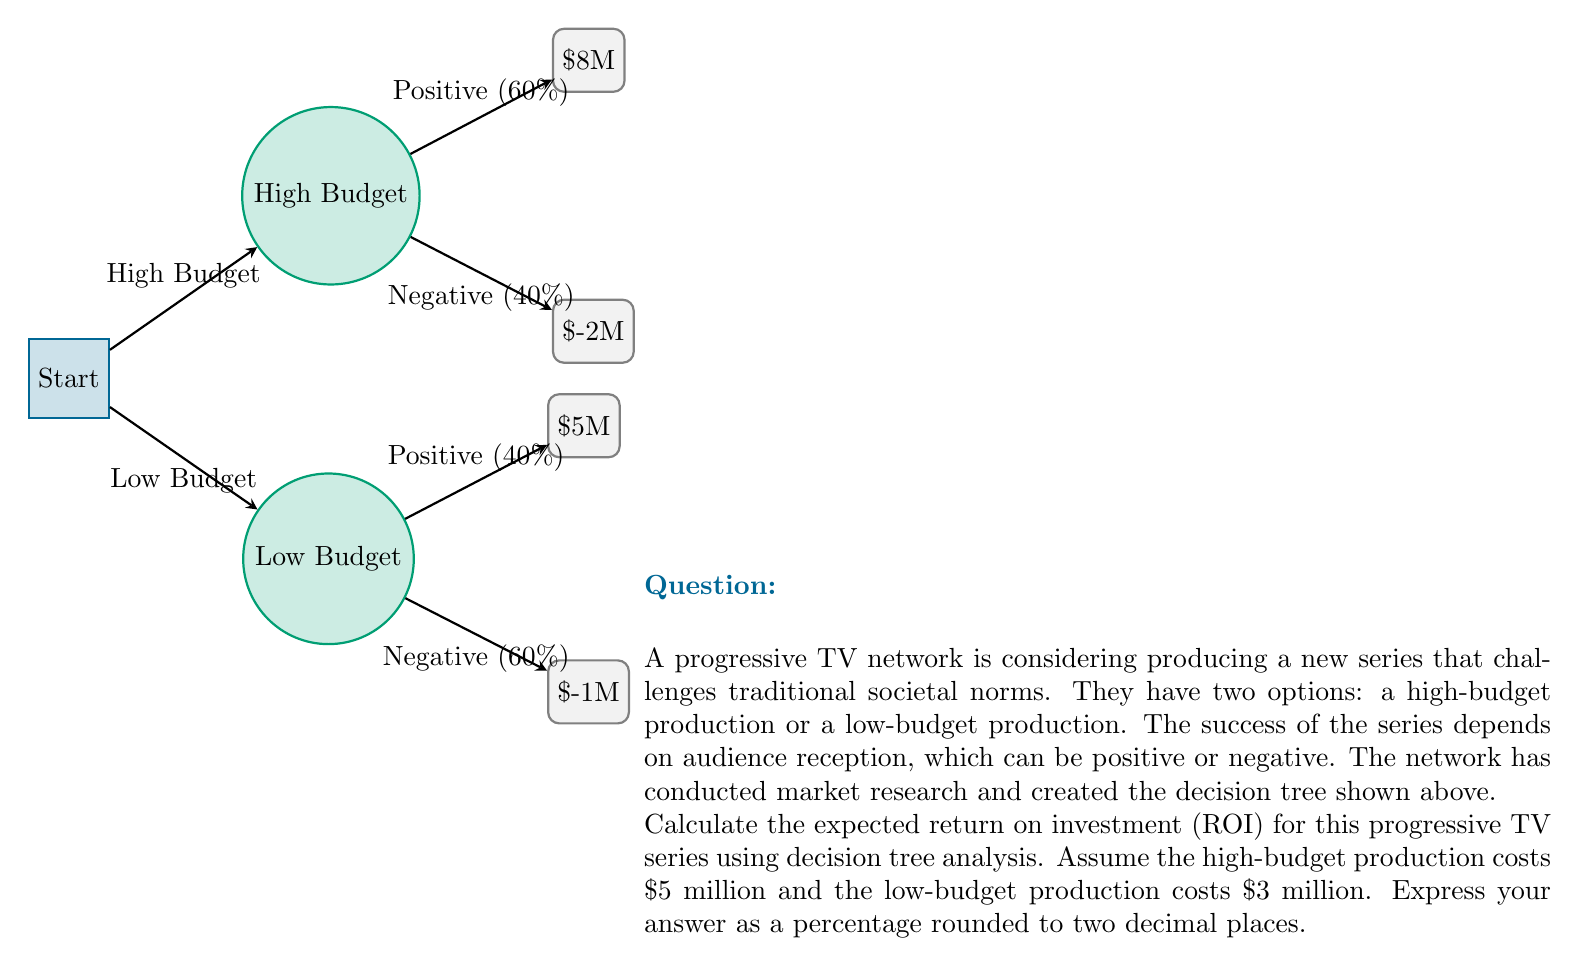Can you solve this math problem? Let's approach this step-by-step:

1) First, we need to calculate the expected value (EV) for each option:

   High-budget option:
   $EV_{high} = 0.60 \times 8M + 0.40 \times (-2M) = 4.8M - 0.8M = 4M$

   Low-budget option:
   $EV_{low} = 0.40 \times 5M + 0.60 \times (-1M) = 2M - 0.6M = 1.4M$

2) The optimal decision is to choose the option with the higher expected value, which is the high-budget option with an EV of $4M.

3) To calculate ROI, we use the formula:

   $ROI = \frac{\text{Net Profit}}{\text{Investment Cost}} \times 100\%$

4) For the high-budget option:
   Net Profit = Expected Value = $4M
   Investment Cost = $5M

   $ROI = \frac{4M}{5M} \times 100\% = 0.8 \times 100\% = 80\%$

5) Therefore, the expected ROI is 80.00%.
Answer: 80.00% 